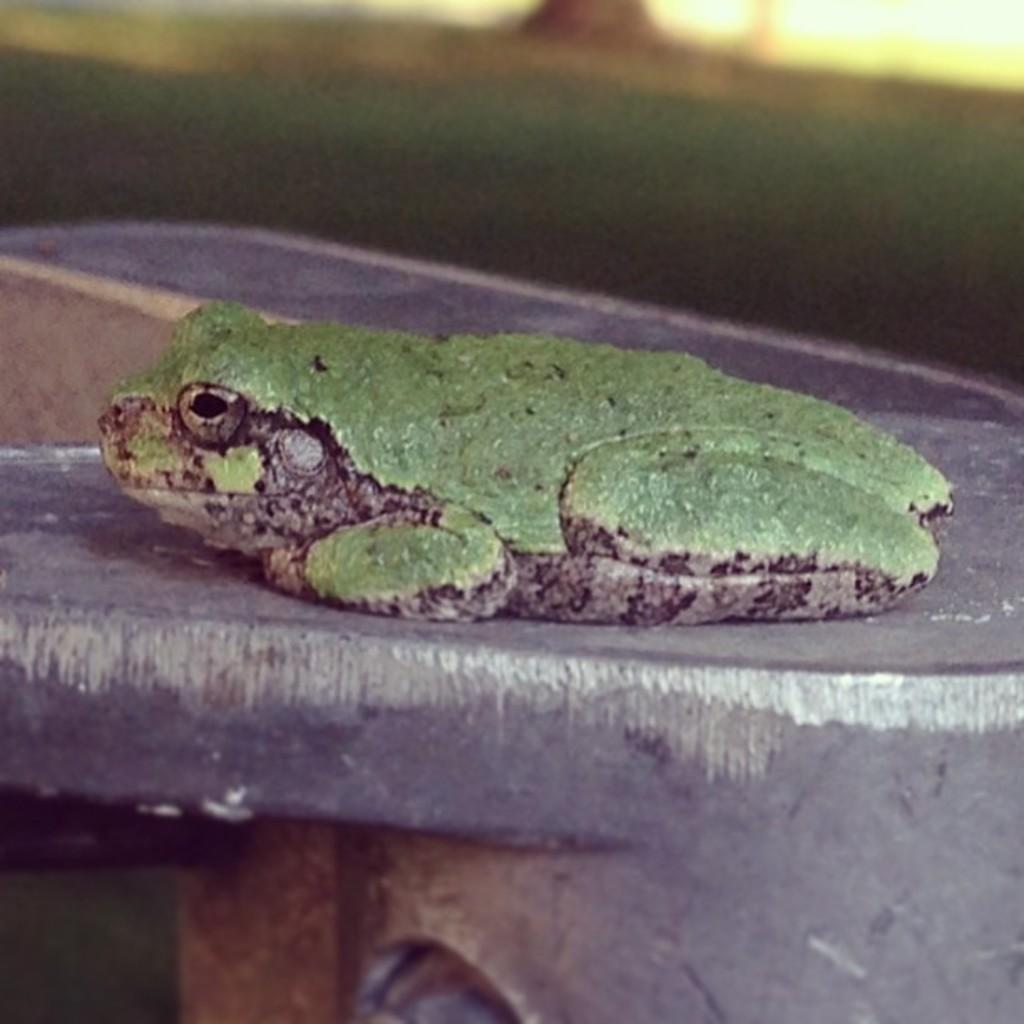Please provide a concise description of this image. In this picture we can see a frog on an object and in the background we can see the grass and it is blurry. 